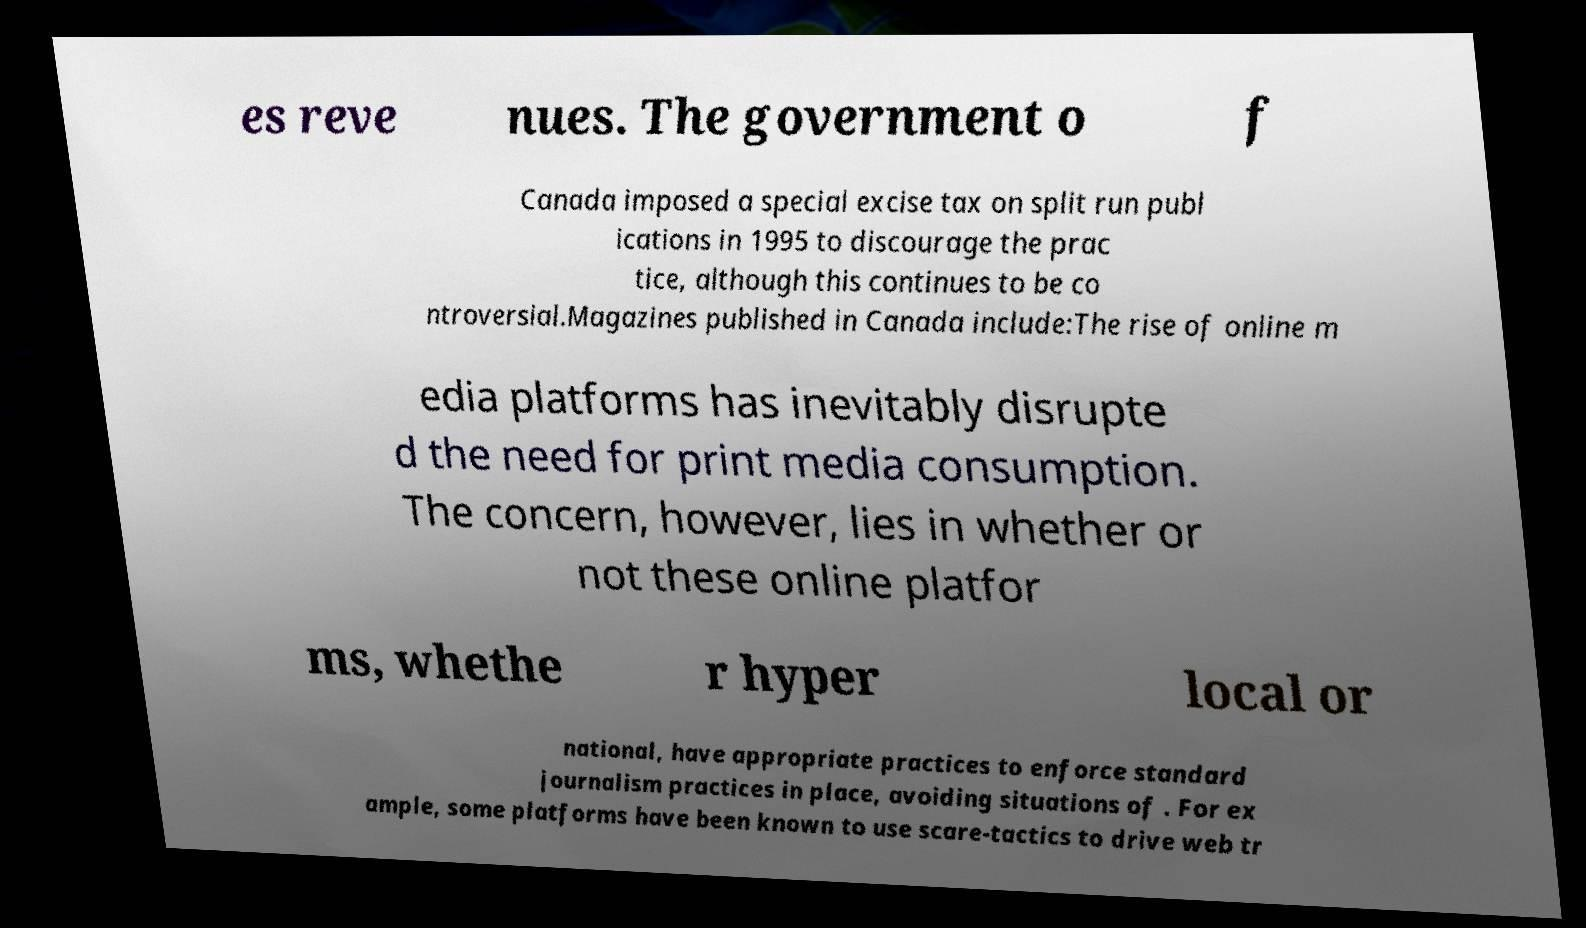Please read and relay the text visible in this image. What does it say? es reve nues. The government o f Canada imposed a special excise tax on split run publ ications in 1995 to discourage the prac tice, although this continues to be co ntroversial.Magazines published in Canada include:The rise of online m edia platforms has inevitably disrupte d the need for print media consumption. The concern, however, lies in whether or not these online platfor ms, whethe r hyper local or national, have appropriate practices to enforce standard journalism practices in place, avoiding situations of . For ex ample, some platforms have been known to use scare-tactics to drive web tr 